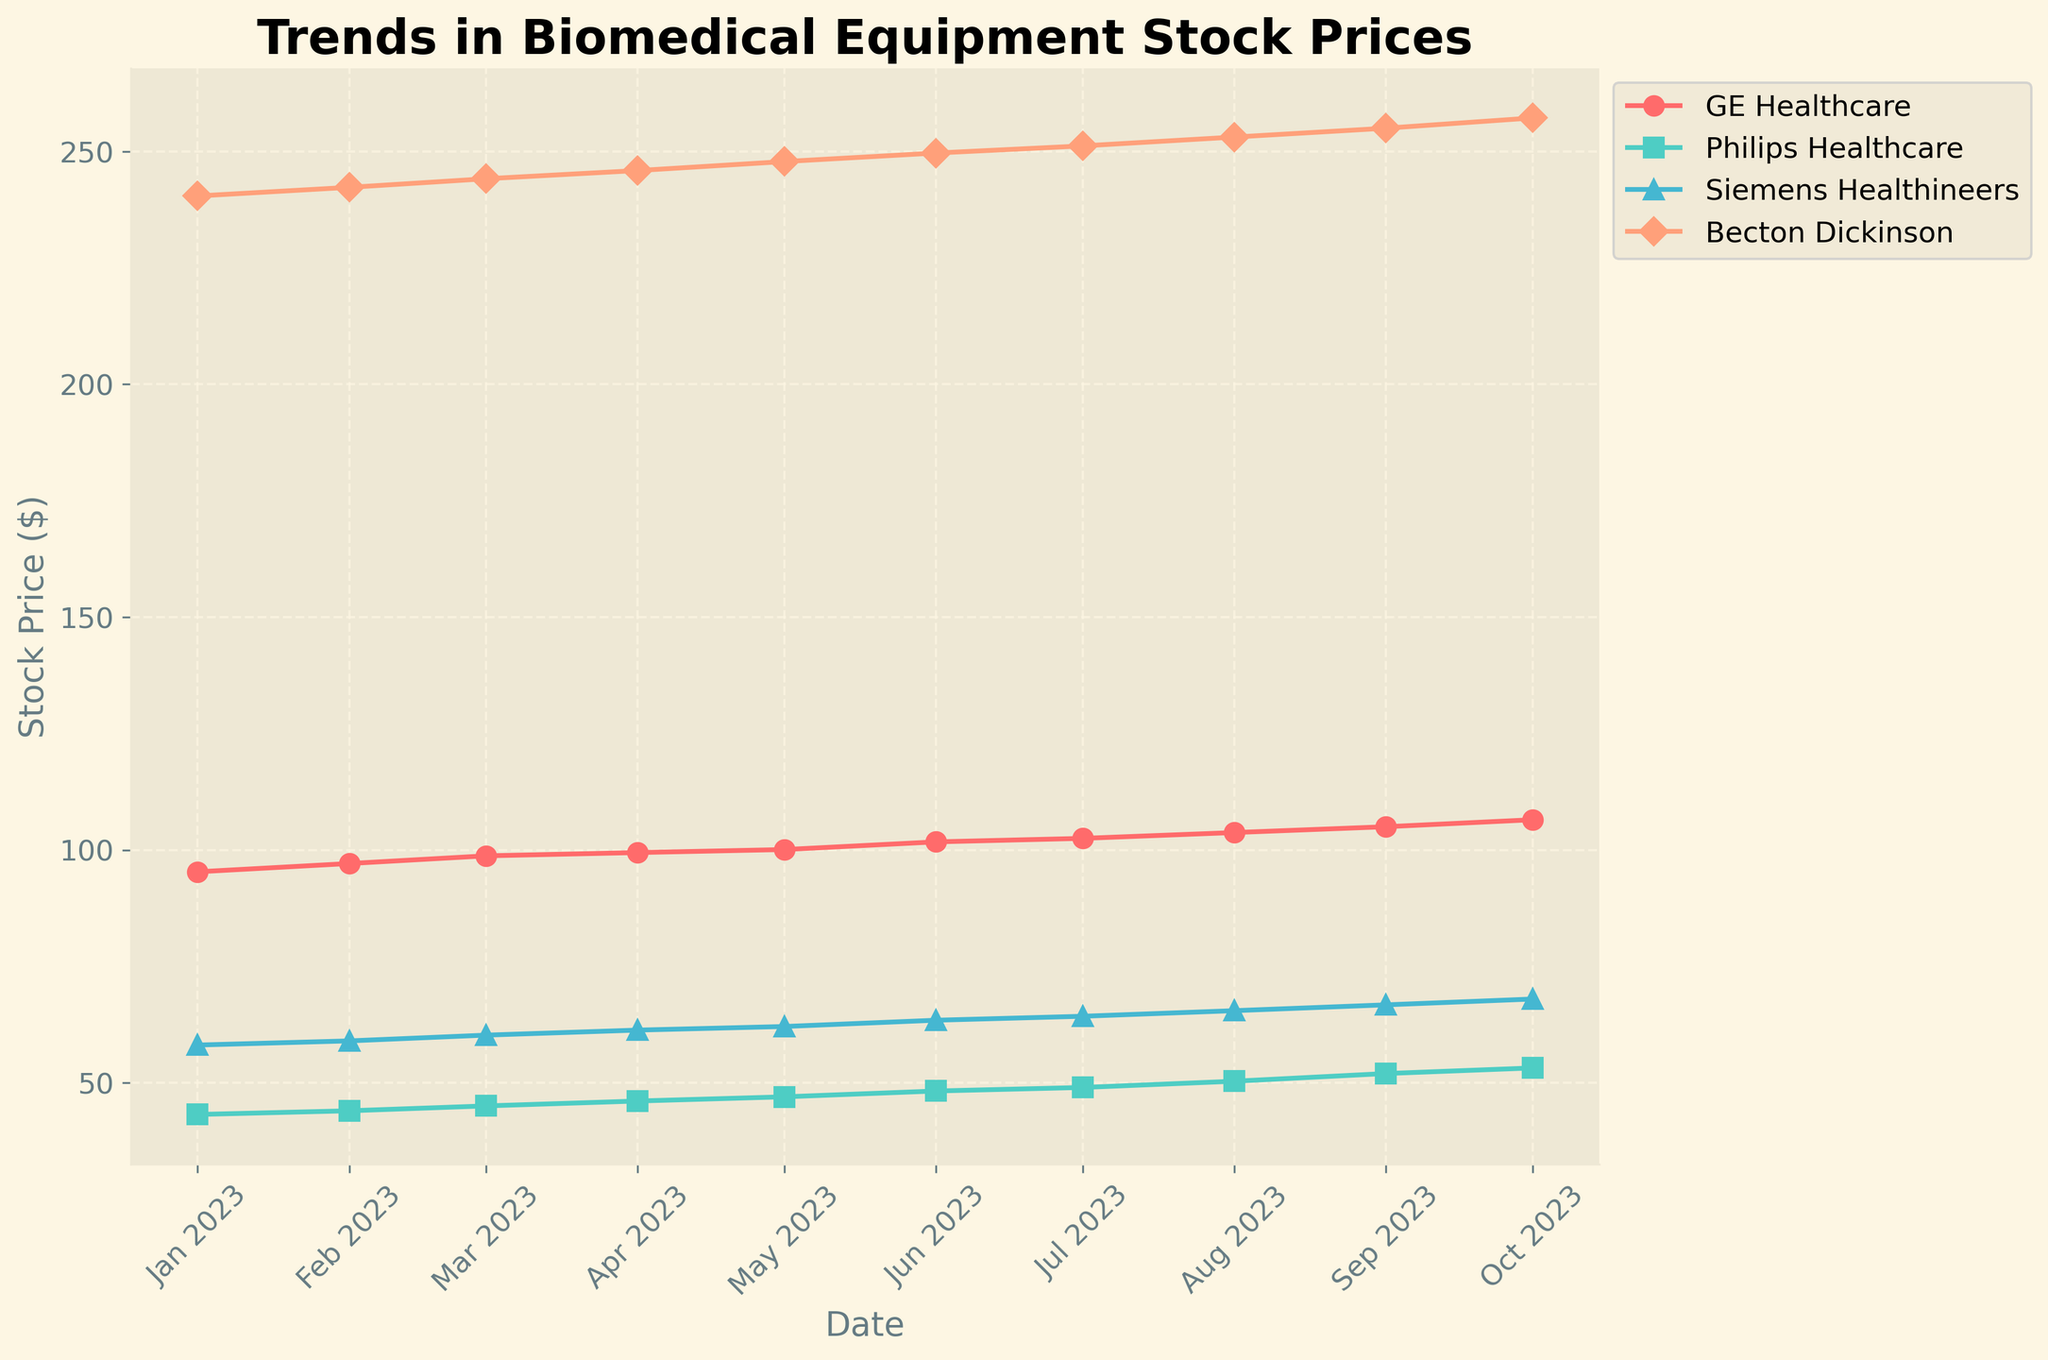What is the title of the figure? The title specifies the main topic of the visualized data. It is typically located at the top of the plot. Here, the plot title is "Trends in Biomedical Equipment Stock Prices".
Answer: Trends in Biomedical Equipment Stock Prices What is the stock price of GE Healthcare on January 1, 2023? We can locate the January 2023 data point for GE Healthcare on the x-axis and check the corresponding y-axis value to find the stock price.
Answer: 95.32 Which company had the highest stock price in October 2023? To identify the company with the highest stock price in October 2023, we look at the y-axis values of each company on the October 2023 marker on the x-axis. The company with the highest y-axis value has the highest stock price. Here, Becton Dickinson has the highest price.
Answer: Becton Dickinson How did Philips Healthcare's stock price change from January to October 2023? To find this, we locate the stock prices of Philips Healthcare in January (43.21) and October (53.20) and calculate the difference by subtracting the January price from the October price.
Answer: It increased by 10.99 Which company shows the greatest increase in stock price over the period from January to October 2023? Calculate the change for each company by subtracting the January stock price from the October one. Compare the results to find the greatest increase: GE Healthcare (106.50 - 95.32), Philips Healthcare (53.20 - 43.21), Siemens Healthineers (68.00 - 58.12), Becton Dickinson (257.20 - 240.45).
Answer: GE Healthcare Which company maintains the most stable stock price throughout the period shown? Stability can be assessed by examining stock price fluctuations. Becton Dickinson shows the least fluctuation from its original stock price (240.45 to 257.20) compared to the others.
Answer: Becton Dickinson What is the average stock price of Siemens Healthineers from January to October 2023? Sum the monthly stock prices of Siemens Healthineers (58.12 + 59.01 + 60.25 + 61.33 + 62.10 + 63.45 + 64.30 + 65.50 + 66.75 + 68.00) and divide by the number of months (10).
Answer: 62.981 Which company's stock price was closest to 50 dollars at any point within the period? Locate each company's stock prices on the plot and identify the one closest to 50 dollars. Philips Healthcare's stock price in August (50.35) is closest to 50.
Answer: Philips Healthcare 